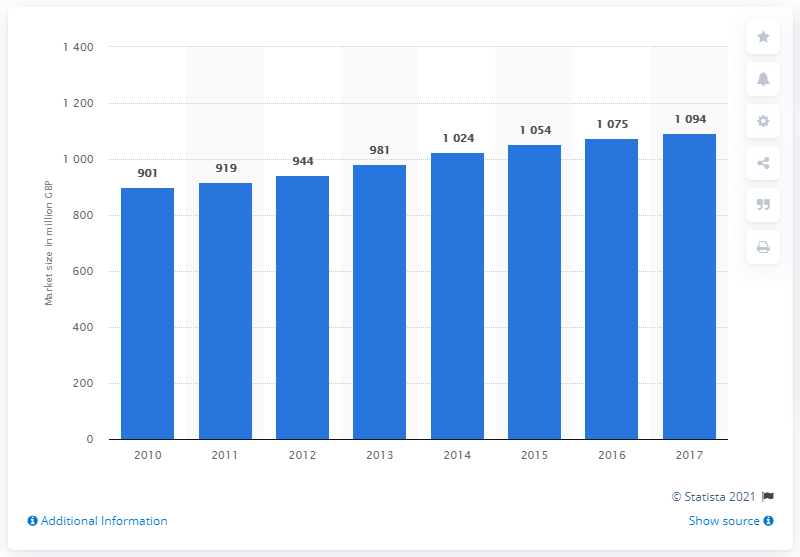Highlight a few significant elements in this photo. The market size forecast for the infrastructure solutions segment in the UK was conducted in 2010. 